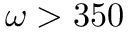<formula> <loc_0><loc_0><loc_500><loc_500>\omega > 3 5 0</formula> 